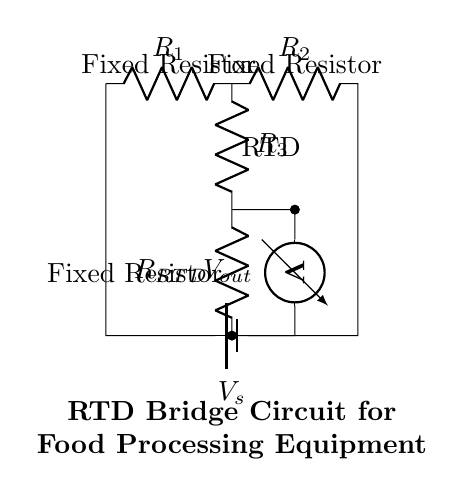What type of circuit is depicted? The circuit is a bridge circuit, as it is designed with components arranged in a way that forms a closed loop, allowing for balanced output voltages when the resistances are equal.
Answer: Bridge circuit How many resistors are in the circuit? There are four resistors present in the circuit: two fixed resistors, one resistance temperature detector (RTD), and a variable resistor used for balancing.
Answer: Four resistors What is the function of the resistance temperature detector (RTD)? The RTD is used to measure temperature changes by changing its resistance based on temperature fluctuations, which can be read as a voltage change in the circuit.
Answer: Temperature measurement What is the output voltage labeled as? The output voltage in the circuit is labeled as Vout, which is the voltage measured across the RTD and the fixed resistor in the middle of the bridge.
Answer: Vout What happens when the RTD resistance increases? When the RTD resistance increases, it causes an imbalance in the bridge, changing the output voltage (Vout) and indicating a rise in temperature, which signals a need for control in food processing equipment.
Answer: Output voltage increases What do the fixed resistors represent in this circuit context? The fixed resistors are used to establish a reference resistance level against which the change in resistance from the RTD can be measured, aiding in accurate temperature detection.
Answer: Reference resistance 